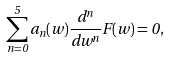<formula> <loc_0><loc_0><loc_500><loc_500>\sum _ { n = 0 } ^ { 5 } a _ { n } ( w ) { \frac { { d ^ { n } } } { { d w ^ { n } } } } F ( w ) = 0 ,</formula> 